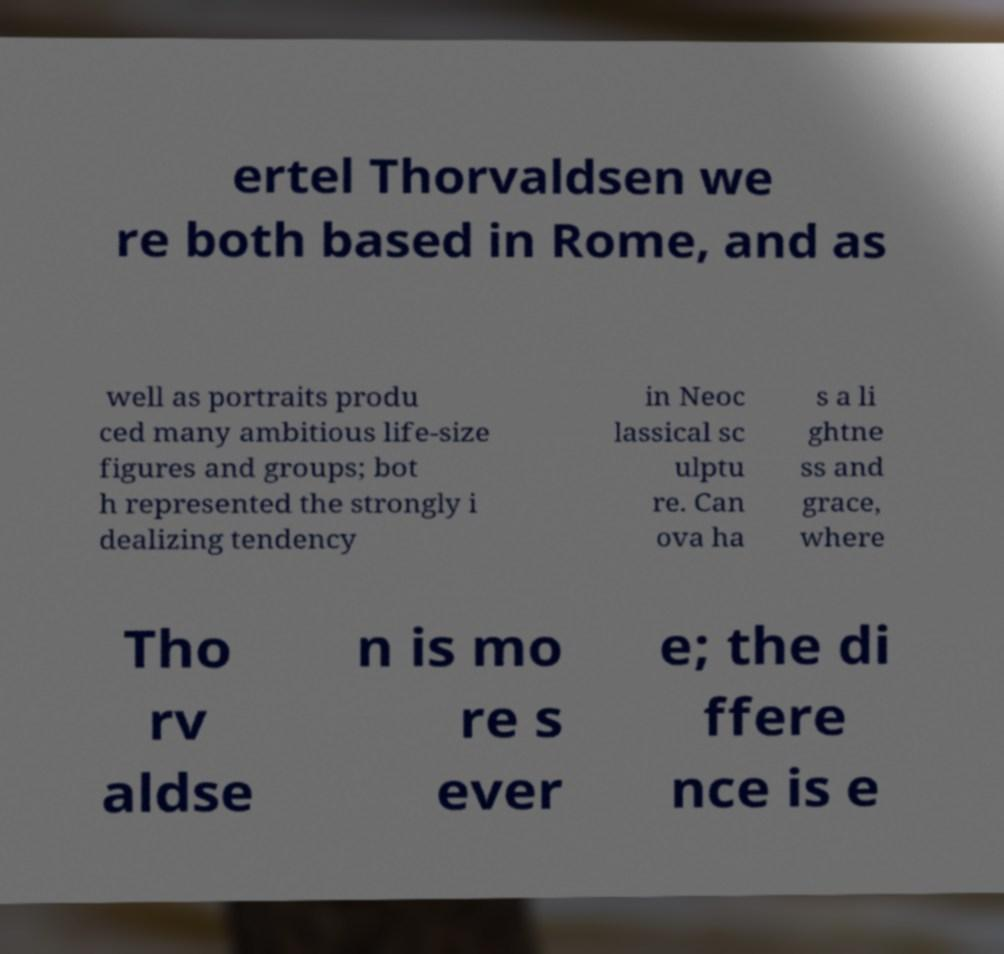Can you read and provide the text displayed in the image?This photo seems to have some interesting text. Can you extract and type it out for me? ertel Thorvaldsen we re both based in Rome, and as well as portraits produ ced many ambitious life-size figures and groups; bot h represented the strongly i dealizing tendency in Neoc lassical sc ulptu re. Can ova ha s a li ghtne ss and grace, where Tho rv aldse n is mo re s ever e; the di ffere nce is e 